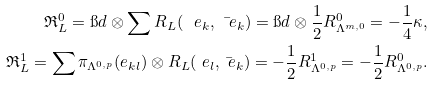<formula> <loc_0><loc_0><loc_500><loc_500>\mathfrak { R } ^ { 0 } _ { L } = \i d \otimes \sum R _ { L } ( \ e _ { k } , \bar { \ e } _ { k } ) = \i d \otimes \frac { 1 } { 2 } R _ { \Lambda ^ { m , 0 } } ^ { 0 } = - \frac { 1 } { 4 } \kappa , \\ \mathfrak { R } ^ { 1 } _ { L } = \sum \pi _ { \Lambda ^ { 0 , p } } ( e _ { k l } ) \otimes R _ { L } ( \ e _ { l } , \bar { \ e } _ { k } ) = - \frac { 1 } { 2 } R _ { \Lambda ^ { 0 , p } } ^ { 1 } = - \frac { 1 } { 2 } R _ { \Lambda ^ { 0 , p } } ^ { 0 } .</formula> 